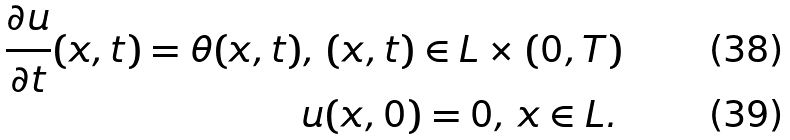Convert formula to latex. <formula><loc_0><loc_0><loc_500><loc_500>& & \frac { \partial u } { \partial t } ( x , t ) = \theta ( x , t ) , \, ( x , t ) \in L \times ( 0 , T ) \\ & & u ( x , 0 ) = 0 , \, x \in L . \,</formula> 